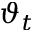<formula> <loc_0><loc_0><loc_500><loc_500>\vartheta _ { t }</formula> 